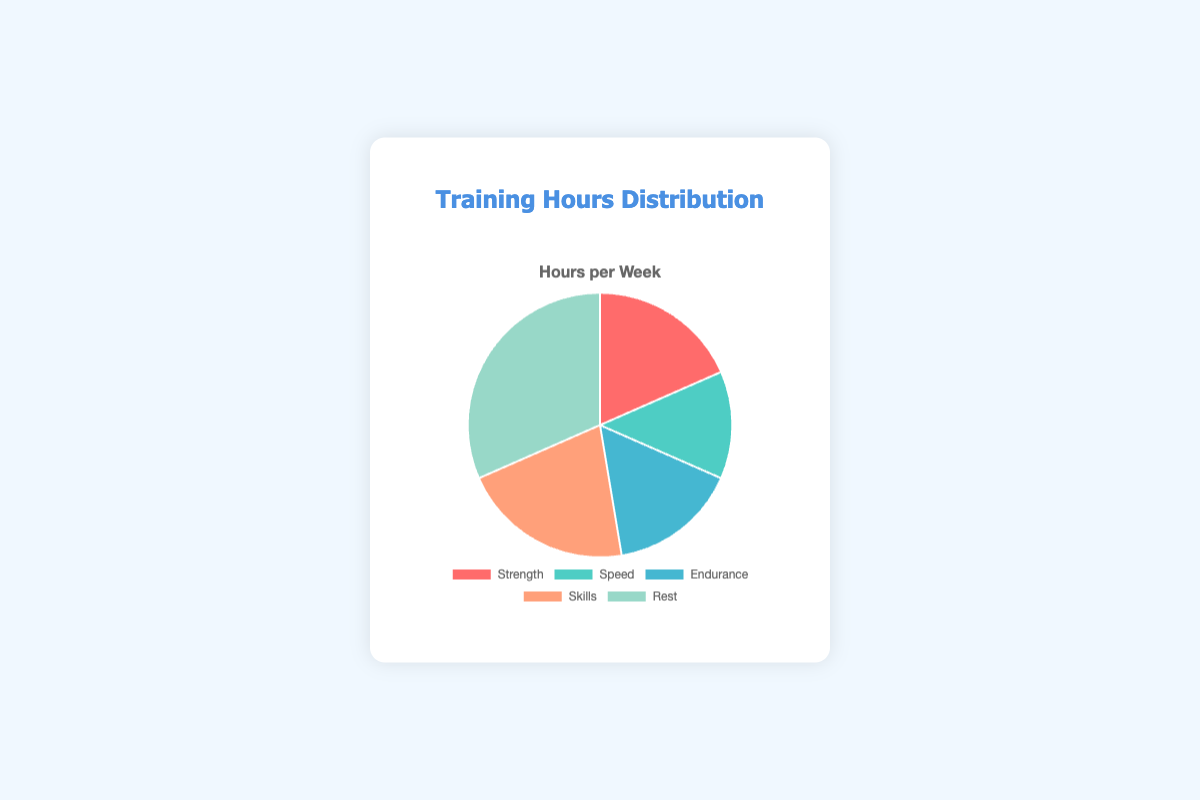What's the total number of training hours per week? Sum up all the training hours: Strength (7) + Speed (5) + Endurance (6) + Skills (8) + Rest (12) = 38 hours
Answer: 38 Which category has the maximum training hours? Looking at the distribution, Rest has the highest value with 12 hours
Answer: Rest How many more hours are spent on Skills compared to Speed? Skills training is 8 hours, and Speed training is 5 hours. The difference is 8 - 5 = 3 hours
Answer: 3 What percentage of the total training hours is dedicated to Endurance? Calculate the percentage using the formula (Endurance Hours / Total Hours) * 100 = (6 / 38) * 100 ≈ 15.79%
Answer: 15.79% If Rest hours were reduced by 4 hours and those hours were added to Strength, what would be the new ratio of Rest to Strength hours? New Rest hours = 12 - 4 = 8, New Strength hours = 7 + 4 = 11. Ratio of Rest to Strength is 8:11
Answer: 8:11 Between Strength and Endurance, which category shows fewer hours and by how much? Strength has 7 hours, and Endurance has 6 hours. Strength has fewer hours by 1 hour
Answer: 1 Combined, how many hours are dedicated to Speed and Endurance training? Sum of Speed and Endurance training hours: 5 + 6 = 11 hours
Answer: 11 What is the average number of hours spent on the categories excluding Rest? Total hours for Strength, Speed, Endurance, and Skills = 7 + 5 + 6 + 8 = 26. Number of categories = 4. Average = 26 / 4 = 6.5 hours
Answer: 6.5 What is the second smallest category in terms of training hours? Order the hours: Strength (7), Speed (5), Endurance (6), Skills (8), Rest (12), the second smallest is Endurance with 6 hours
Answer: Endurance 